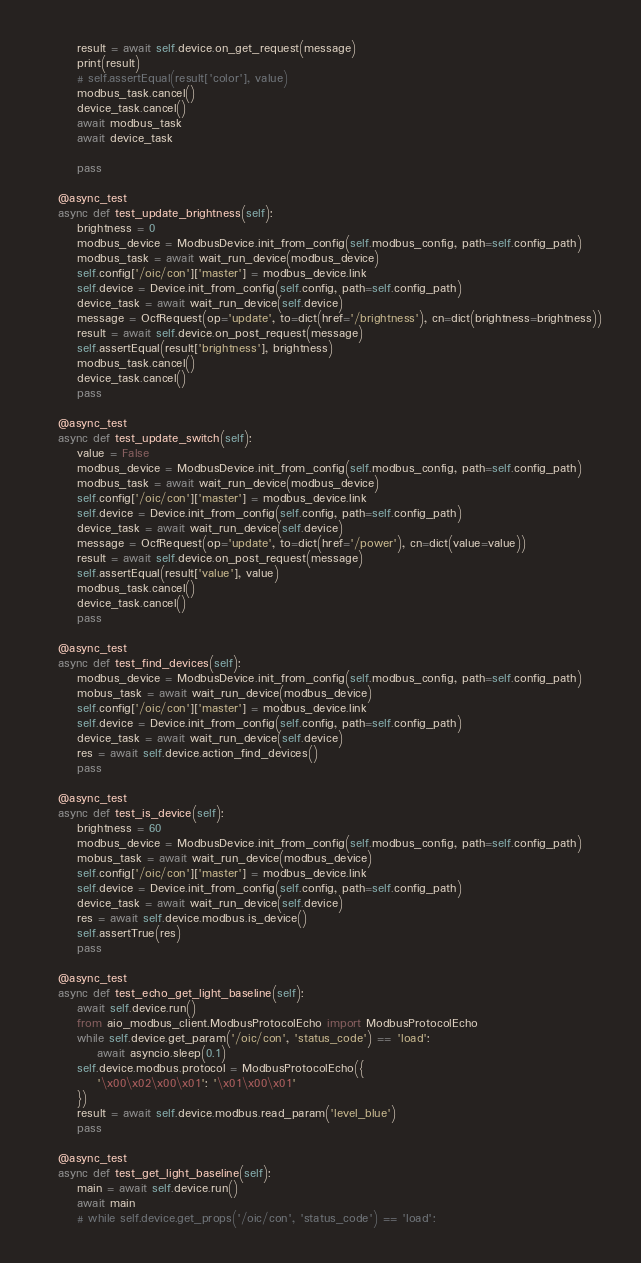Convert code to text. <code><loc_0><loc_0><loc_500><loc_500><_Python_>        result = await self.device.on_get_request(message)
        print(result)
        # self.assertEqual(result['color'], value)
        modbus_task.cancel()
        device_task.cancel()
        await modbus_task
        await device_task

        pass

    @async_test
    async def test_update_brightness(self):
        brightness = 0
        modbus_device = ModbusDevice.init_from_config(self.modbus_config, path=self.config_path)
        modbus_task = await wait_run_device(modbus_device)
        self.config['/oic/con']['master'] = modbus_device.link
        self.device = Device.init_from_config(self.config, path=self.config_path)
        device_task = await wait_run_device(self.device)
        message = OcfRequest(op='update', to=dict(href='/brightness'), cn=dict(brightness=brightness))
        result = await self.device.on_post_request(message)
        self.assertEqual(result['brightness'], brightness)
        modbus_task.cancel()
        device_task.cancel()
        pass

    @async_test
    async def test_update_switch(self):
        value = False
        modbus_device = ModbusDevice.init_from_config(self.modbus_config, path=self.config_path)
        modbus_task = await wait_run_device(modbus_device)
        self.config['/oic/con']['master'] = modbus_device.link
        self.device = Device.init_from_config(self.config, path=self.config_path)
        device_task = await wait_run_device(self.device)
        message = OcfRequest(op='update', to=dict(href='/power'), cn=dict(value=value))
        result = await self.device.on_post_request(message)
        self.assertEqual(result['value'], value)
        modbus_task.cancel()
        device_task.cancel()
        pass

    @async_test
    async def test_find_devices(self):
        modbus_device = ModbusDevice.init_from_config(self.modbus_config, path=self.config_path)
        mobus_task = await wait_run_device(modbus_device)
        self.config['/oic/con']['master'] = modbus_device.link
        self.device = Device.init_from_config(self.config, path=self.config_path)
        device_task = await wait_run_device(self.device)
        res = await self.device.action_find_devices()
        pass

    @async_test
    async def test_is_device(self):
        brightness = 60
        modbus_device = ModbusDevice.init_from_config(self.modbus_config, path=self.config_path)
        mobus_task = await wait_run_device(modbus_device)
        self.config['/oic/con']['master'] = modbus_device.link
        self.device = Device.init_from_config(self.config, path=self.config_path)
        device_task = await wait_run_device(self.device)
        res = await self.device.modbus.is_device()
        self.assertTrue(res)
        pass

    @async_test
    async def test_echo_get_light_baseline(self):
        await self.device.run()
        from aio_modbus_client.ModbusProtocolEcho import ModbusProtocolEcho
        while self.device.get_param('/oic/con', 'status_code') == 'load':
            await asyncio.sleep(0.1)
        self.device.modbus.protocol = ModbusProtocolEcho({
            '\x00\x02\x00\x01': '\x01\x00\x01'
        })
        result = await self.device.modbus.read_param('level_blue')
        pass

    @async_test
    async def test_get_light_baseline(self):
        main = await self.device.run()
        await main
        # while self.device.get_props('/oic/con', 'status_code') == 'load':</code> 